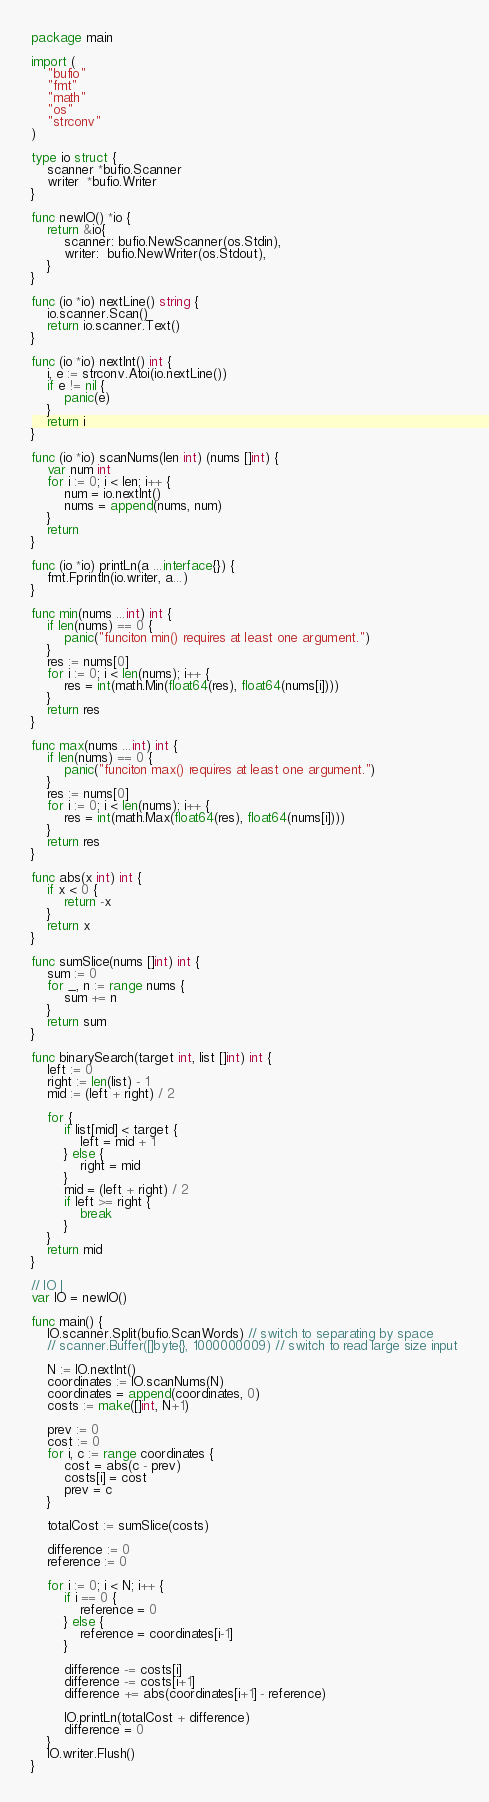<code> <loc_0><loc_0><loc_500><loc_500><_Go_>package main

import (
	"bufio"
	"fmt"
	"math"
	"os"
	"strconv"
)

type io struct {
	scanner *bufio.Scanner
	writer  *bufio.Writer
}

func newIO() *io {
	return &io{
		scanner: bufio.NewScanner(os.Stdin),
		writer:  bufio.NewWriter(os.Stdout),
	}
}

func (io *io) nextLine() string {
	io.scanner.Scan()
	return io.scanner.Text()
}

func (io *io) nextInt() int {
	i, e := strconv.Atoi(io.nextLine())
	if e != nil {
		panic(e)
	}
	return i
}

func (io *io) scanNums(len int) (nums []int) {
	var num int
	for i := 0; i < len; i++ {
		num = io.nextInt()
		nums = append(nums, num)
	}
	return
}

func (io *io) printLn(a ...interface{}) {
	fmt.Fprintln(io.writer, a...)
}

func min(nums ...int) int {
	if len(nums) == 0 {
		panic("funciton min() requires at least one argument.")
	}
	res := nums[0]
	for i := 0; i < len(nums); i++ {
		res = int(math.Min(float64(res), float64(nums[i])))
	}
	return res
}

func max(nums ...int) int {
	if len(nums) == 0 {
		panic("funciton max() requires at least one argument.")
	}
	res := nums[0]
	for i := 0; i < len(nums); i++ {
		res = int(math.Max(float64(res), float64(nums[i])))
	}
	return res
}

func abs(x int) int {
	if x < 0 {
		return -x
	}
	return x
}

func sumSlice(nums []int) int {
	sum := 0
	for _, n := range nums {
		sum += n
	}
	return sum
}

func binarySearch(target int, list []int) int {
	left := 0
	right := len(list) - 1
	mid := (left + right) / 2

	for {
		if list[mid] < target {
			left = mid + 1
		} else {
			right = mid
		}
		mid = (left + right) / 2
		if left >= right {
			break
		}
	}
	return mid
}

// IO |
var IO = newIO()

func main() {
	IO.scanner.Split(bufio.ScanWords) // switch to separating by space
	// scanner.Buffer([]byte{}, 1000000009) // switch to read large size input

	N := IO.nextInt()
	coordinates := IO.scanNums(N)
	coordinates = append(coordinates, 0)
	costs := make([]int, N+1)

	prev := 0
	cost := 0
	for i, c := range coordinates {
		cost = abs(c - prev)
		costs[i] = cost
		prev = c
	}

	totalCost := sumSlice(costs)

	difference := 0
	reference := 0

	for i := 0; i < N; i++ {
		if i == 0 {
			reference = 0
		} else {
			reference = coordinates[i-1]
		}

		difference -= costs[i]
		difference -= costs[i+1]
		difference += abs(coordinates[i+1] - reference)

		IO.printLn(totalCost + difference)
		difference = 0
	}
	IO.writer.Flush()
}
</code> 